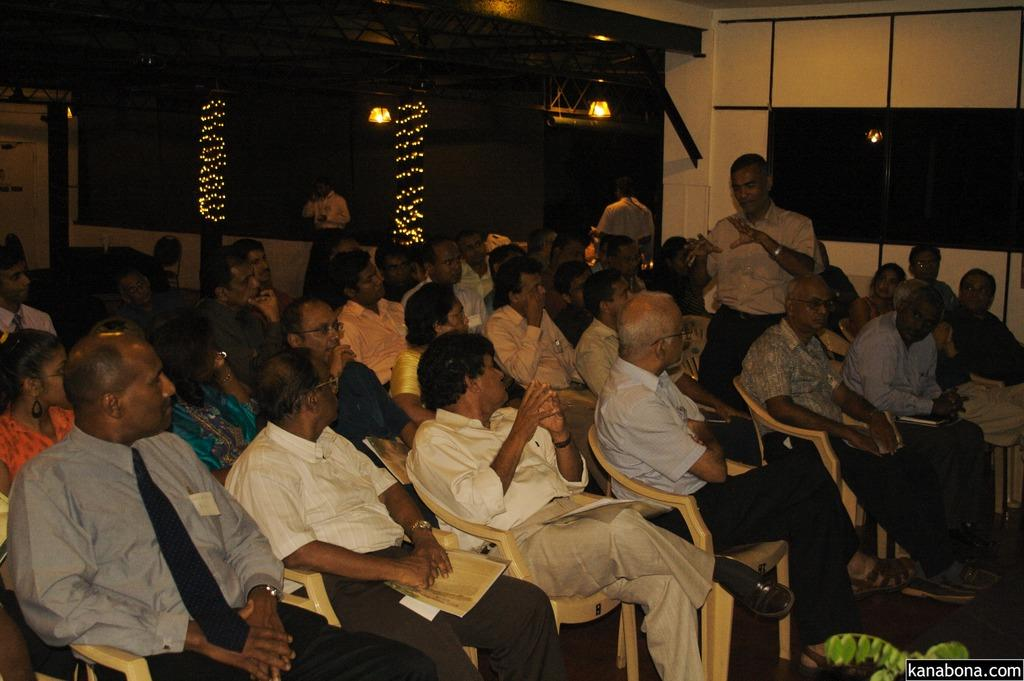What are the people in the image doing? There is a group of people sitting on chairs, and there are people standing in the image. What can be seen in the background of the image? There is a wall and lights in the background of the image. What is visible in the bottom right side of the image? Leaves and text are visible in the bottom right side of the image. What type of flower is the grandfather holding in the image? There is no grandfather or flower present in the image. 